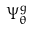<formula> <loc_0><loc_0><loc_500><loc_500>\Psi _ { \theta } ^ { g }</formula> 